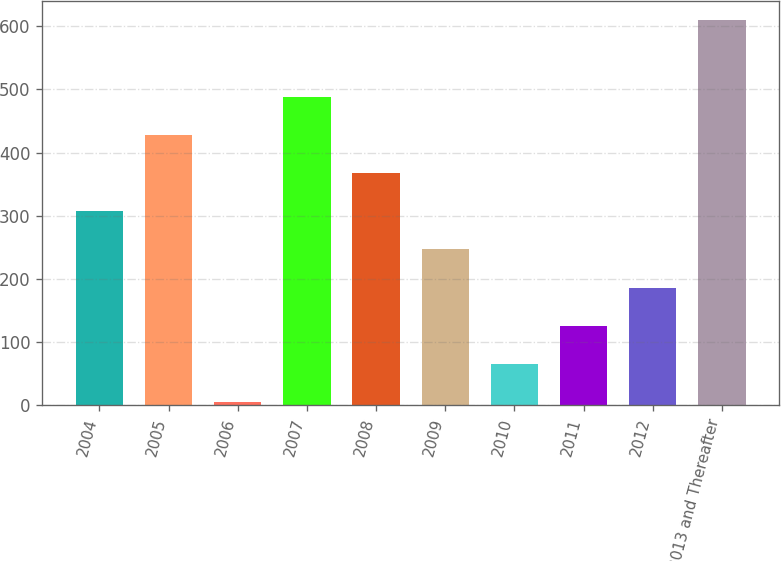<chart> <loc_0><loc_0><loc_500><loc_500><bar_chart><fcel>2004<fcel>2005<fcel>2006<fcel>2007<fcel>2008<fcel>2009<fcel>2010<fcel>2011<fcel>2012<fcel>2013 and Thereafter<nl><fcel>307<fcel>427.8<fcel>5<fcel>488.2<fcel>367.4<fcel>246.6<fcel>65.4<fcel>125.8<fcel>186.2<fcel>609<nl></chart> 